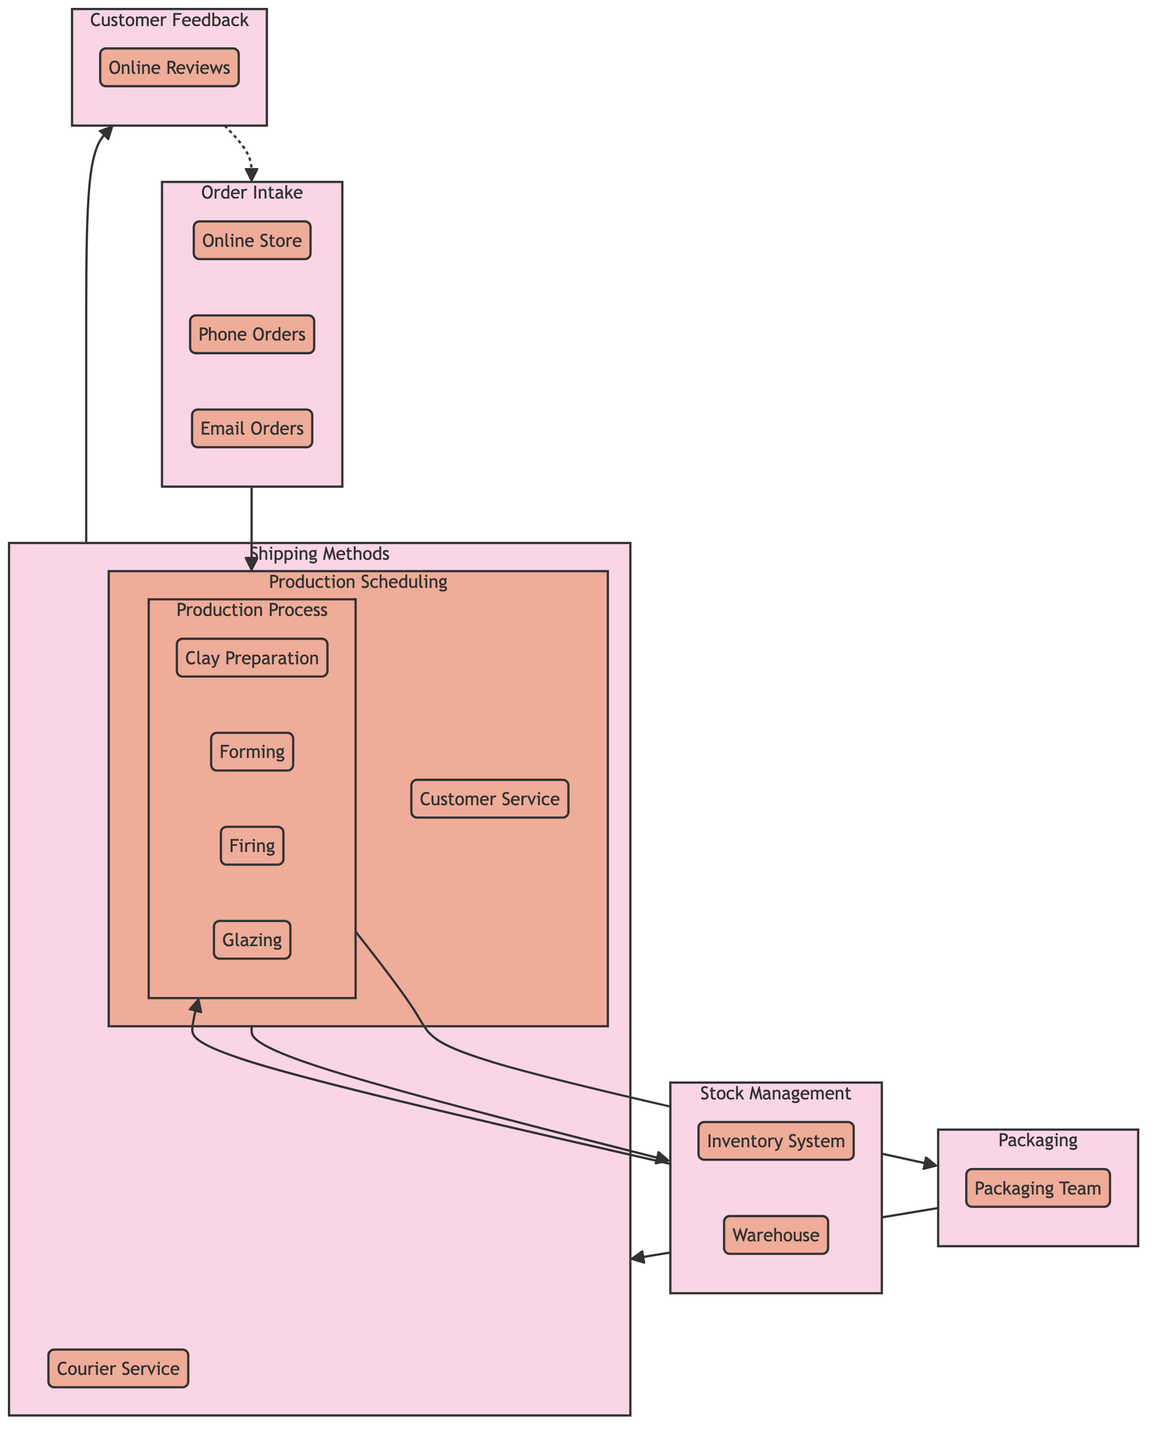What is the first process in the fulfillment network? The fulfillment network begins with the "Order Intake" process, which is the first step before production scheduling.
Answer: Order Intake How many entities are involved in the packaging process? The "Packaging" process includes one entity, which is the "Packaging Team."
Answer: 1 Which entities are responsible for tracking inventory? The "Stock Management" process includes the "Inventory System" and "Warehouse," both responsible for tracking inventory.
Answer: Inventory System, Warehouse What is the last process before customer feedback in the diagram? The "Shipping Methods" process comes directly before the "Customer Feedback" stage, indicating it is the last step before obtaining customer insights.
Answer: Shipping Methods How many tasks does the Production Planner have? The "Production Planner" has three tasks associated with it: "Schedule Jobs," "Allocate Resources," and "Set Deadlines." Counting these gives a total of three tasks.
Answer: 3 What is the role of Customer Service in the fulfillment network? The "Customer Service" entity is involved in the "Customer Feedback" process, handling feedback from customers and updating records.
Answer: Receive Feedback, Respond to Feedback, Update Records Which process follows Stock Management? The "Production Process" directly follows "Stock Management" in the flow of the fulfillment network.
Answer: Production Process Which shipping method involves a courier? The "Courier Service" is the method that specifically involves a courier for delivering customer orders.
Answer: Courier Service What happens to the Customer Feedback loop in relation to Order Intake? The diagram indicates that the Customer Feedback loop connects back to the Order Intake process, allowing for the integration of customer feedback into future orders.
Answer: It loops back to Order Intake 